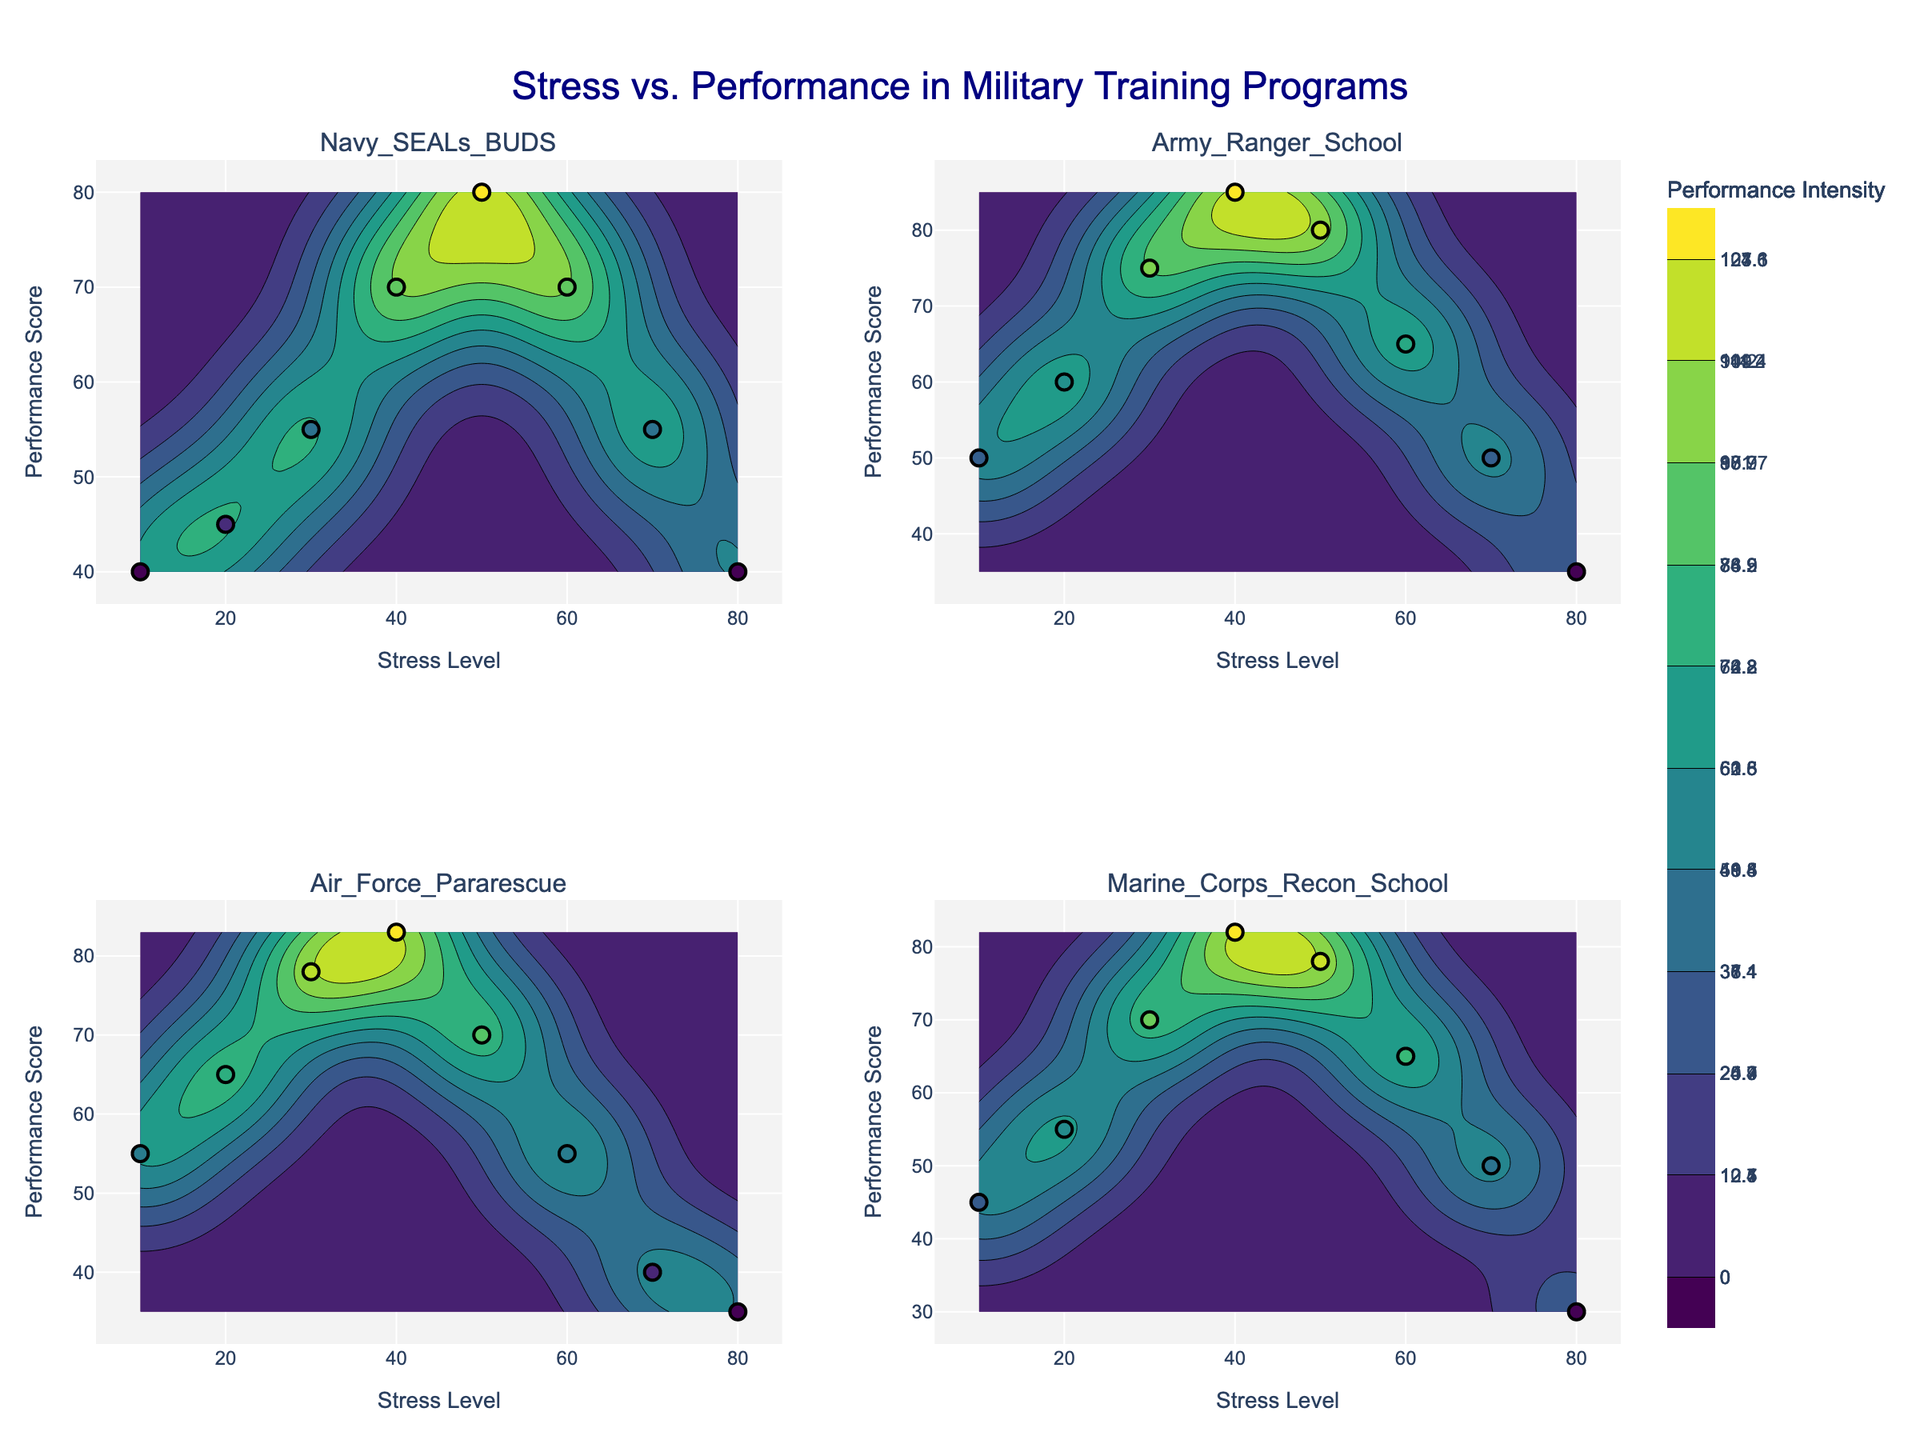What is the title of the figure? The title is displayed at the top center of the figure. It reads "Stress vs. Performance in Military Training Programs".
Answer: Stress vs. Performance in Military Training Programs Which training program has the highest peak performance intensity according to the contours? By examining the color intensity in the contour plots, Army Ranger School has the highest peak performance intensity, indicated by the most vibrant color concentration.
Answer: Army Ranger School At what stress level does the Navy SEALs BUD/S training program reach its peak performance score? From the subplot of Navy SEALs BUD/S, the highest performance score of 80 occurs at a stress level of 50.
Answer: 50 Compare the performance scores of Army Ranger School and Air Force Pararescue at a stress level of 40. Which is higher? Locate the stress level of 40 on both subplots and compare the performance scores at this stress level. Army Ranger School has a performance score of 85, while Air Force Pararescue shows a score of 83.
Answer: Army Ranger School What is the range of performance scores for Marine Corps Recon School? The y-axis of the Marine Corps Recon School subplot shows performance scores ranging from 30 to 82.
Answer: 30 to 82 How many data points are plotted in each subplot? By counting the visible markers in each subplot, there are 8 data points in each subplot for the respective training programs.
Answer: 8 What common trend can be observed across all training programs regarding stress level and performance score? For all subplots, performance scores initially increase with rising stress levels until a certain point, after which they start to decline. This pattern suggests an optimal stress level range for peak performance in each training program.
Answer: Performance increases then decreases Where on the stress level axis do the performance scores for Air Force Pararescue start to decline? Observing the Air Force Pararescue subplot, the performance scores start to decline after reaching a peak at a stress level of 40 and gradually decrease beyond this point.
Answer: 40 Which training program has the broadest range of stress levels resulting in a performance score greater than 70? By examining the widths of the contour levels, Army Ranger School displays the broadest range of stress levels with performance scores above 70, ranging approximately from 30 to 50.
Answer: Army Ranger School 